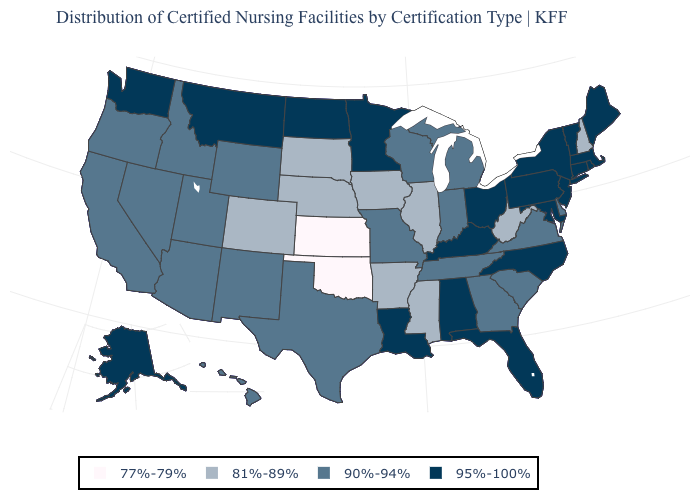Name the states that have a value in the range 81%-89%?
Keep it brief. Arkansas, Colorado, Illinois, Iowa, Mississippi, Nebraska, New Hampshire, South Dakota, West Virginia. What is the value of New Mexico?
Quick response, please. 90%-94%. What is the value of Florida?
Short answer required. 95%-100%. Does Florida have the same value as South Carolina?
Short answer required. No. What is the lowest value in states that border New Jersey?
Write a very short answer. 90%-94%. Which states have the highest value in the USA?
Write a very short answer. Alabama, Alaska, Connecticut, Florida, Kentucky, Louisiana, Maine, Maryland, Massachusetts, Minnesota, Montana, New Jersey, New York, North Carolina, North Dakota, Ohio, Pennsylvania, Rhode Island, Vermont, Washington. Name the states that have a value in the range 77%-79%?
Write a very short answer. Kansas, Oklahoma. What is the highest value in the USA?
Give a very brief answer. 95%-100%. Name the states that have a value in the range 81%-89%?
Keep it brief. Arkansas, Colorado, Illinois, Iowa, Mississippi, Nebraska, New Hampshire, South Dakota, West Virginia. What is the highest value in states that border North Dakota?
Be succinct. 95%-100%. What is the lowest value in the USA?
Short answer required. 77%-79%. Does Nevada have a lower value than Pennsylvania?
Concise answer only. Yes. What is the value of Maryland?
Be succinct. 95%-100%. Name the states that have a value in the range 77%-79%?
Give a very brief answer. Kansas, Oklahoma. Does the map have missing data?
Keep it brief. No. 